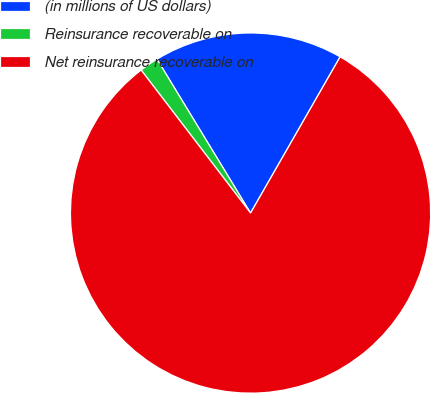<chart> <loc_0><loc_0><loc_500><loc_500><pie_chart><fcel>(in millions of US dollars)<fcel>Reinsurance recoverable on<fcel>Net reinsurance recoverable on<nl><fcel>16.98%<fcel>1.7%<fcel>81.32%<nl></chart> 